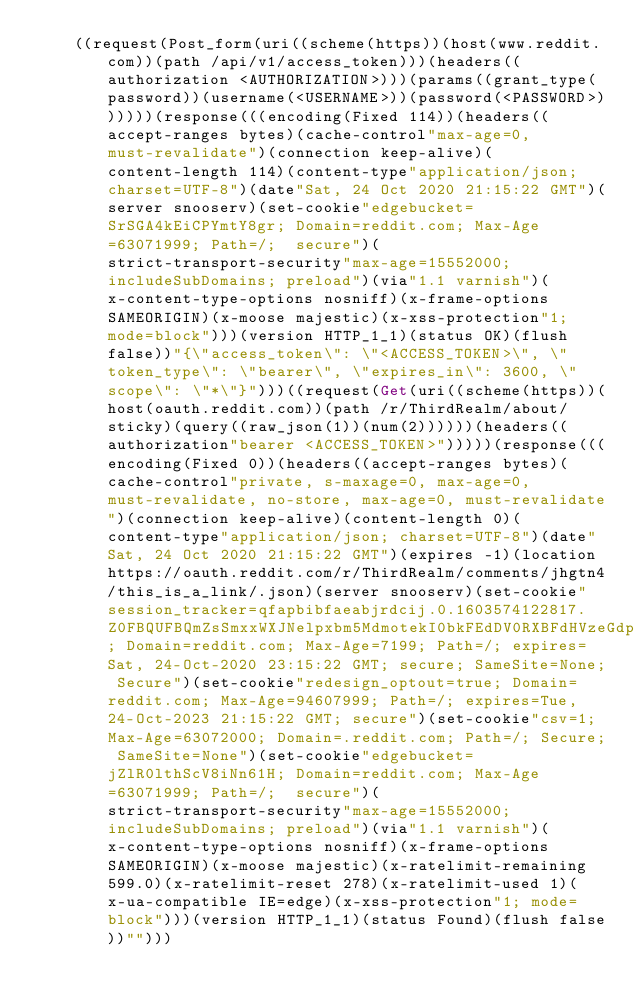Convert code to text. <code><loc_0><loc_0><loc_500><loc_500><_Lisp_>    ((request(Post_form(uri((scheme(https))(host(www.reddit.com))(path /api/v1/access_token)))(headers((authorization <AUTHORIZATION>)))(params((grant_type(password))(username(<USERNAME>))(password(<PASSWORD>))))))(response(((encoding(Fixed 114))(headers((accept-ranges bytes)(cache-control"max-age=0, must-revalidate")(connection keep-alive)(content-length 114)(content-type"application/json; charset=UTF-8")(date"Sat, 24 Oct 2020 21:15:22 GMT")(server snooserv)(set-cookie"edgebucket=SrSGA4kEiCPYmtY8gr; Domain=reddit.com; Max-Age=63071999; Path=/;  secure")(strict-transport-security"max-age=15552000; includeSubDomains; preload")(via"1.1 varnish")(x-content-type-options nosniff)(x-frame-options SAMEORIGIN)(x-moose majestic)(x-xss-protection"1; mode=block")))(version HTTP_1_1)(status OK)(flush false))"{\"access_token\": \"<ACCESS_TOKEN>\", \"token_type\": \"bearer\", \"expires_in\": 3600, \"scope\": \"*\"}")))((request(Get(uri((scheme(https))(host(oauth.reddit.com))(path /r/ThirdRealm/about/sticky)(query((raw_json(1))(num(2))))))(headers((authorization"bearer <ACCESS_TOKEN>")))))(response(((encoding(Fixed 0))(headers((accept-ranges bytes)(cache-control"private, s-maxage=0, max-age=0, must-revalidate, no-store, max-age=0, must-revalidate")(connection keep-alive)(content-length 0)(content-type"application/json; charset=UTF-8")(date"Sat, 24 Oct 2020 21:15:22 GMT")(expires -1)(location https://oauth.reddit.com/r/ThirdRealm/comments/jhgtn4/this_is_a_link/.json)(server snooserv)(set-cookie"session_tracker=qfapbibfaeabjrdcij.0.1603574122817.Z0FBQUFBQmZsSmxxWXJNelpxbm5MdmotekI0bkFEdDV0RXBFdHVzeGdpampoS1hmdDNlLTI2NEg5TmlmZE1sN3dmSzRGS01Sb01NT05JY3JURTYtLXZ5LUlmTzFVYWRzbWlVTkd2YVFOZ0xVZjhJWDNONy1OU2JPMHBQdnBNY1JmWldsLWtoZWlncU8; Domain=reddit.com; Max-Age=7199; Path=/; expires=Sat, 24-Oct-2020 23:15:22 GMT; secure; SameSite=None; Secure")(set-cookie"redesign_optout=true; Domain=reddit.com; Max-Age=94607999; Path=/; expires=Tue, 24-Oct-2023 21:15:22 GMT; secure")(set-cookie"csv=1; Max-Age=63072000; Domain=.reddit.com; Path=/; Secure; SameSite=None")(set-cookie"edgebucket=jZlR0lthScV8iNn61H; Domain=reddit.com; Max-Age=63071999; Path=/;  secure")(strict-transport-security"max-age=15552000; includeSubDomains; preload")(via"1.1 varnish")(x-content-type-options nosniff)(x-frame-options SAMEORIGIN)(x-moose majestic)(x-ratelimit-remaining 599.0)(x-ratelimit-reset 278)(x-ratelimit-used 1)(x-ua-compatible IE=edge)(x-xss-protection"1; mode=block")))(version HTTP_1_1)(status Found)(flush false))"")))
</code> 